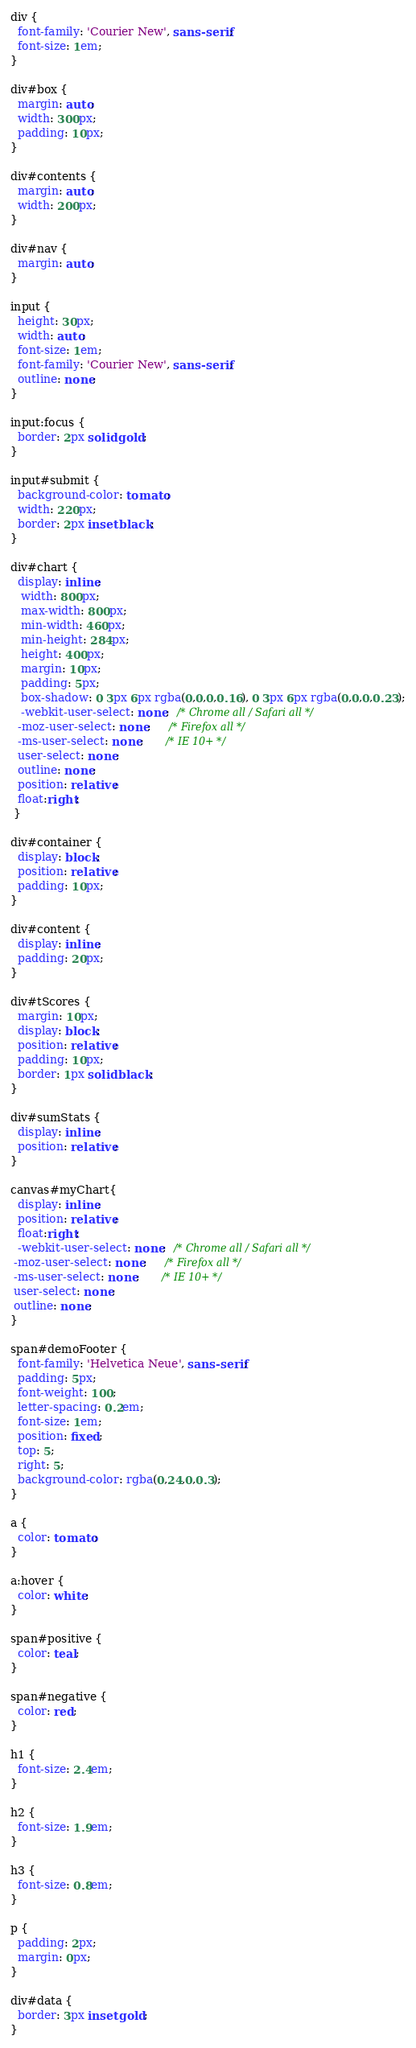<code> <loc_0><loc_0><loc_500><loc_500><_CSS_>div {
  font-family: 'Courier New', sans-serif;
  font-size: 1em;
}

div#box {
  margin: auto;
  width: 300px;
  padding: 10px;
}

div#contents {
  margin: auto;
  width: 200px;
}

div#nav {
  margin: auto;
}

input {
  height: 30px;
  width: auto;
  font-size: 1em;
  font-family: 'Courier New', sans-serif;
  outline: none;
}

input:focus {
  border: 2px solid gold;
}

input#submit {
  background-color: tomato;
  width: 220px;
  border: 2px inset black;
}

div#chart {
  display: inline;
   width: 800px;
   max-width: 800px;
   min-width: 460px;
   min-height: 284px;
   height: 400px;
   margin: 10px;
   padding: 5px;
   box-shadow: 0 3px 6px rgba(0,0,0,0.16), 0 3px 6px rgba(0,0,0,0.23);
   -webkit-user-select: none;  /* Chrome all / Safari all */
  -moz-user-select: none;     /* Firefox all */
  -ms-user-select: none;      /* IE 10+ */
  user-select: none;
  outline: none;
  position: relative;
  float:right;
 }

div#container {
  display: block;
  position: relative;
  padding: 10px;
}

div#content {
  display: inline;
  padding: 20px;
}

div#tScores {
  margin: 10px;
  display: block;
  position: relative;
  padding: 10px;
  border: 1px solid black;
}

div#sumStats {
  display: inline;
  position: relative;
}

canvas#myChart{
  display: inline;
  position: relative;
  float:right;
  -webkit-user-select: none;  /* Chrome all / Safari all */
 -moz-user-select: none;     /* Firefox all */
 -ms-user-select: none;      /* IE 10+ */
 user-select: none;
 outline: none;
}

span#demoFooter {
  font-family: 'Helvetica Neue', sans-serif;
  padding: 5px;
  font-weight: 100;
  letter-spacing: 0.2em;
  font-size: 1em;
  position: fixed;
  top: 5;
  right: 5;
  background-color: rgba(0,24,0,0.3);
}

a {
  color: tomato;
}

a:hover {
  color: white;
}

span#positive {
  color: teal;
}

span#negative {
  color: red;
}

h1 {
  font-size: 2.4em;
}

h2 {
  font-size: 1.9em;
}

h3 {
  font-size: 0.8em;
}

p {
  padding: 2px;
  margin: 0px;
}

div#data {
  border: 3px inset gold;
}
</code> 